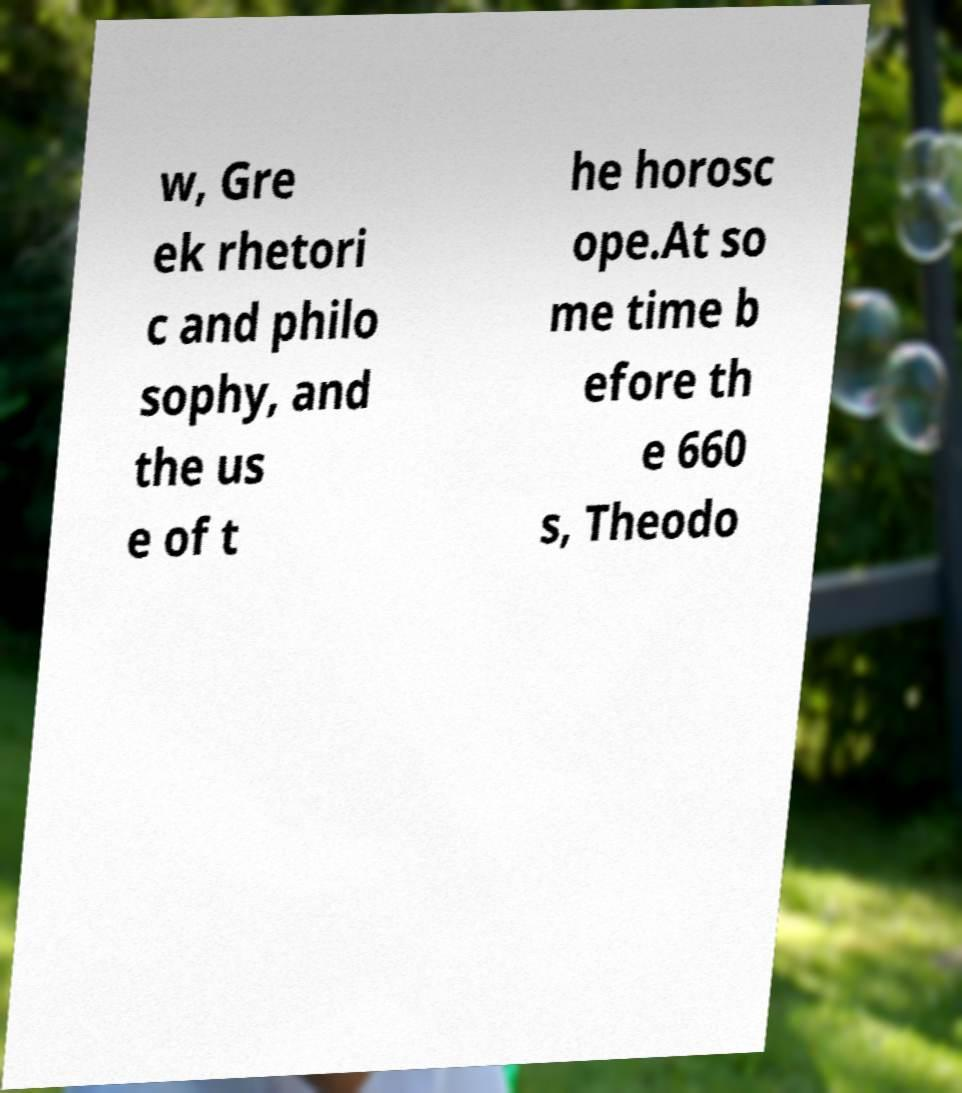There's text embedded in this image that I need extracted. Can you transcribe it verbatim? w, Gre ek rhetori c and philo sophy, and the us e of t he horosc ope.At so me time b efore th e 660 s, Theodo 